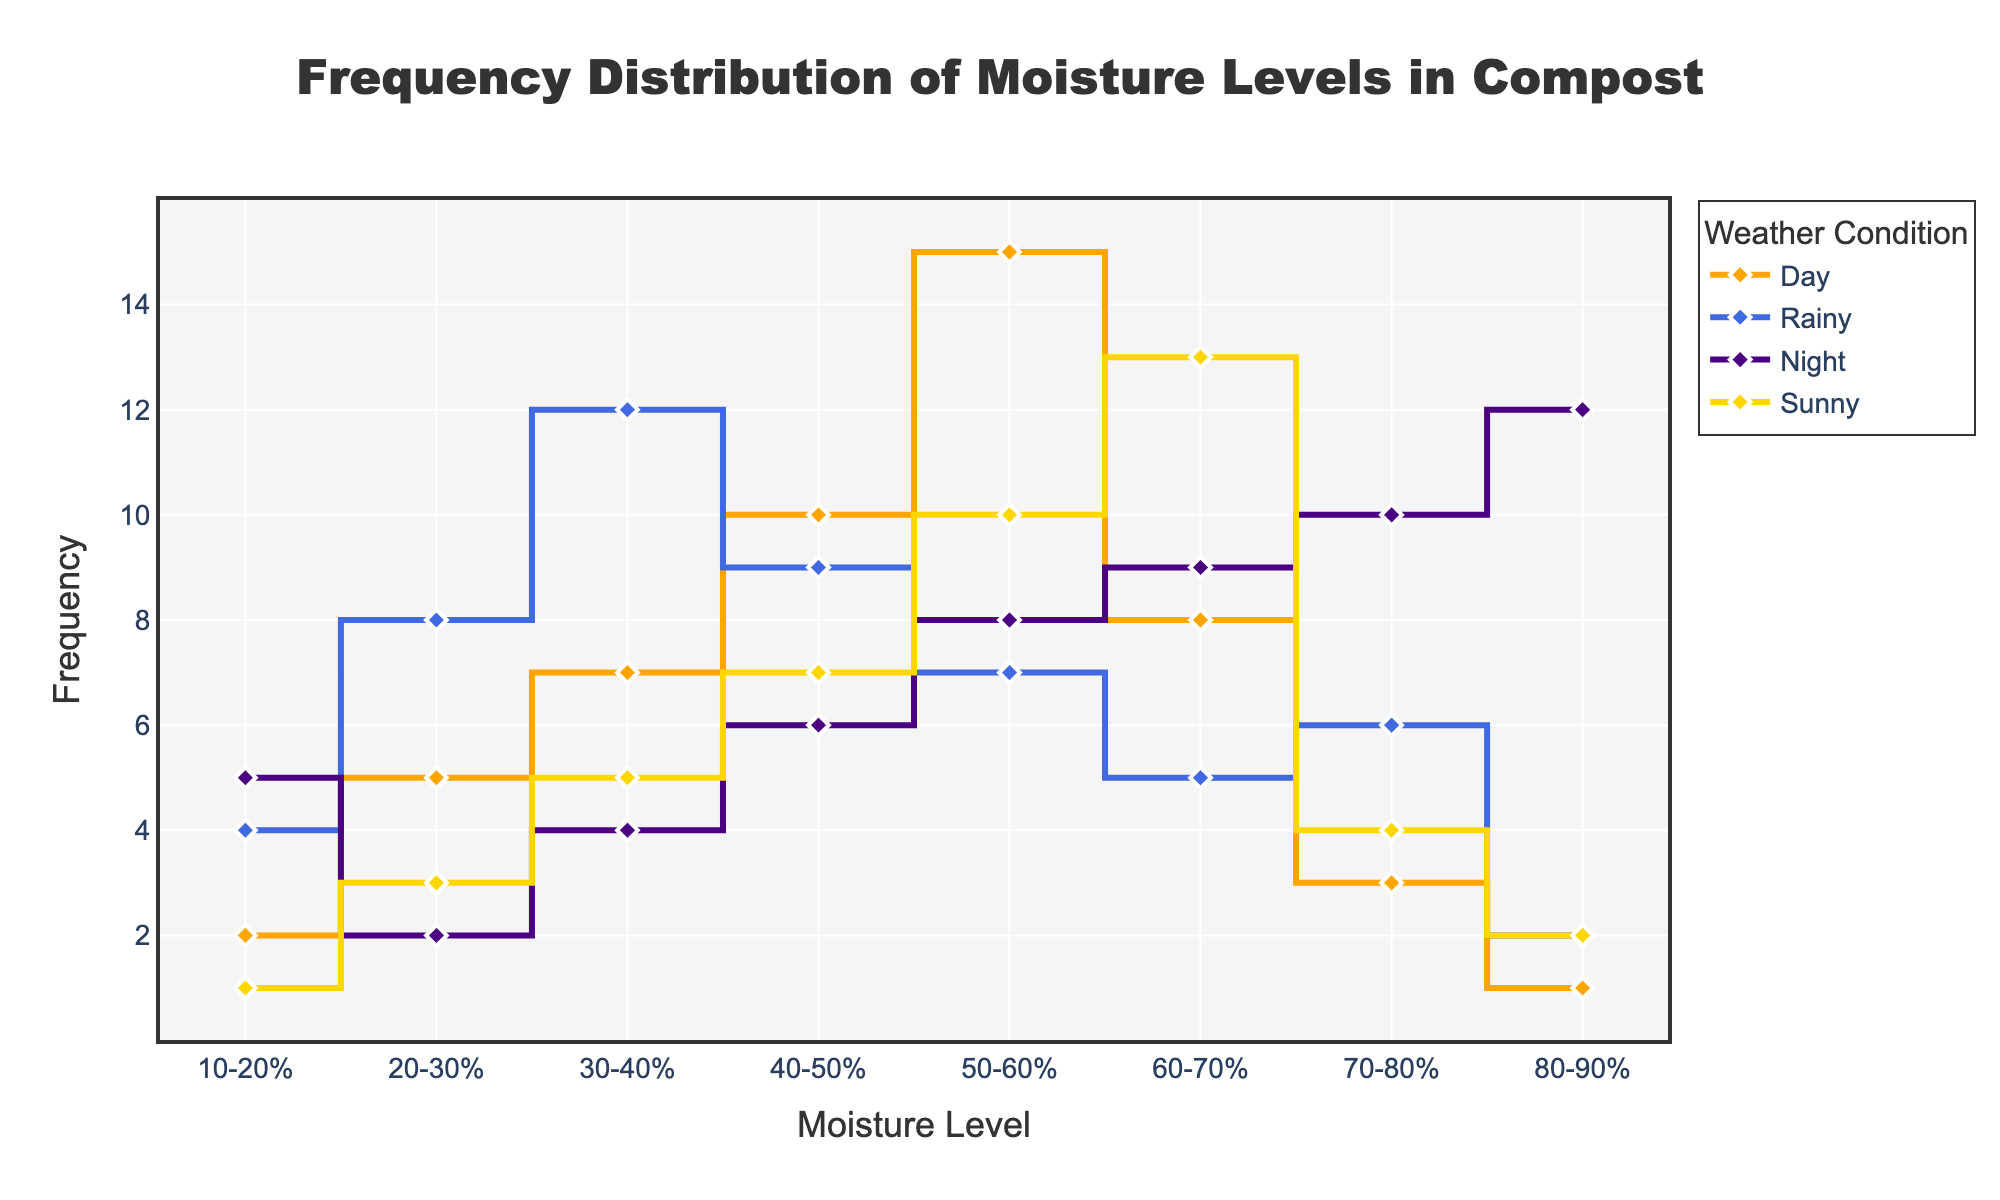What is the title of the plot? The title of the plot is located at the top center of the figure and reads: "Frequency Distribution of Moisture Levels in Compost".
Answer: Frequency Distribution of Moisture Levels in Compost Which weather condition has the highest frequency for the 50-60% moisture level range? At the 50-60% moisture level range, the highest frequency is observed for the "Sunny" condition, as indicated by the highest point in that segment.
Answer: Sunny How many data points are plotted for each weather condition? Each weather condition has a data point for each moisture level range. Since there are 8 moisture level ranges, each condition has 8 data points.
Answer: 8 What is the frequency difference between the 'Day' and 'Rainy' conditions for the 30-40% moisture level range? The frequency for the 'Day' condition is 7, and for the 'Rainy' condition it is 12. The difference is calculated as 12 - 7.
Answer: 5 Which moisture level range has the lowest frequency for the 'Night' condition? In the 'Night' condition, the 10-20% moisture level range has the lowest frequency of 5, as indicated by the lowest point in that segment.
Answer: 10-20% During 'Rainy' weather, which moisture level range shows the highest frequency? The 'Rainy' condition sees the highest frequency at the 30-40% moisture level range, where the frequency is 12.
Answer: 30-40% How does the frequency of the 'Sunny' condition change between the 60-70% and 70-80% moisture level ranges? For the 'Sunny' condition, the frequency decreases from 13 at the 60-70% moisture level range to 4 at the 70-80% level range.
Answer: Decreases What is the average frequency of the 'Day' condition across all moisture levels? To find the average frequency for the 'Day' condition, sum all the frequencies (2+5+7+10+15+8+3+1) and divide by the number of data points (8). The total frequency is 51, so the average is 51/8.
Answer: 6.375 Which moisture level range has the highest total frequency regardless of weather condition? Adding up all frequencies for each moisture level range, the 50-60% range has the highest total (15+7+8+10 = 40).
Answer: 50-60% 